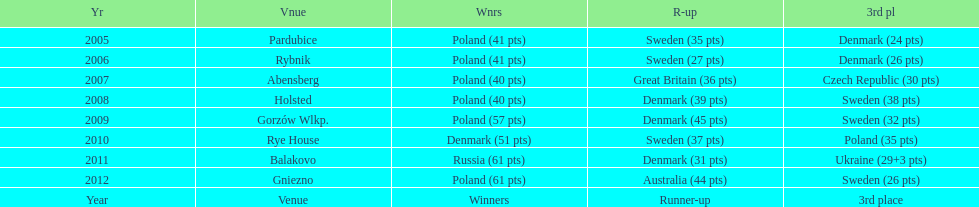With their 2009 first place triumph, how did poland rank in the following year's speedway junior world championship? 3rd place. 